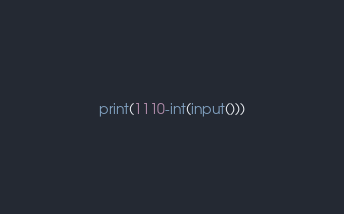<code> <loc_0><loc_0><loc_500><loc_500><_Python_>print(1110-int(input()))</code> 